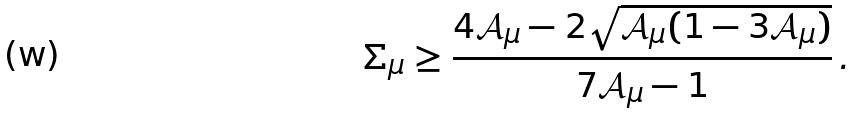<formula> <loc_0><loc_0><loc_500><loc_500>\Sigma _ { \mu } \geq \frac { 4 \mathcal { A } _ { \mu } - 2 \sqrt { \mathcal { A } _ { \mu } ( 1 - 3 \mathcal { A } _ { \mu } ) } } { 7 \mathcal { A } _ { \mu } - 1 } \, .</formula> 